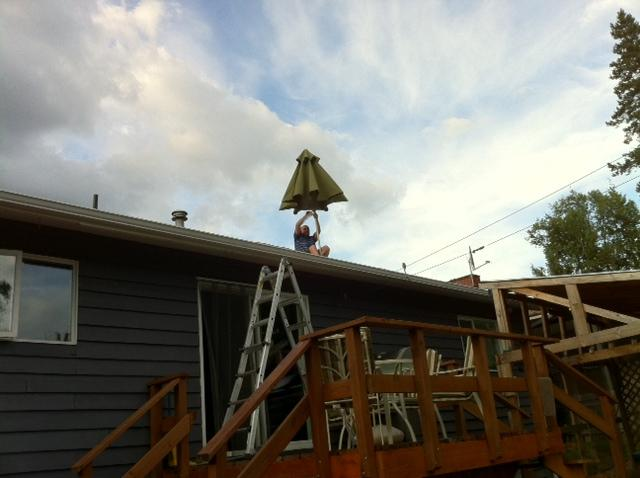What does the item the man is holding provide? shade 